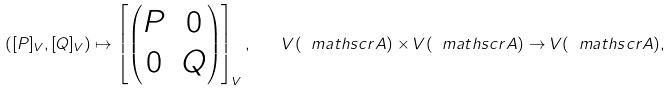Convert formula to latex. <formula><loc_0><loc_0><loc_500><loc_500>\left ( [ P ] _ { V } , [ Q ] _ { V } \right ) \mapsto \left [ \begin{pmatrix} P & 0 \\ 0 & Q \end{pmatrix} \right ] _ { V } , \quad V ( \ m a t h s c r { A } ) \times V ( \ m a t h s c r { A } ) \to V ( \ m a t h s c r { A } ) ,</formula> 